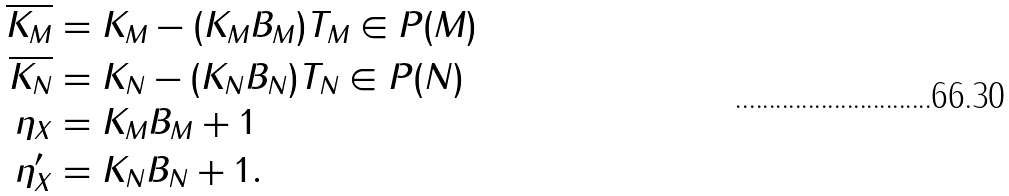Convert formula to latex. <formula><loc_0><loc_0><loc_500><loc_500>\overline { K _ { M } } & = K _ { M } - ( K _ { M } B _ { M } ) T _ { M } \in P ( M ) \\ \overline { K _ { N } } & = K _ { N } - ( K _ { N } B _ { N } ) T _ { N } \in P ( N ) \\ \eta _ { X } & = K _ { M } B _ { M } + 1 \\ \eta _ { X } ^ { \prime } & = K _ { N } B _ { N } + 1 .</formula> 